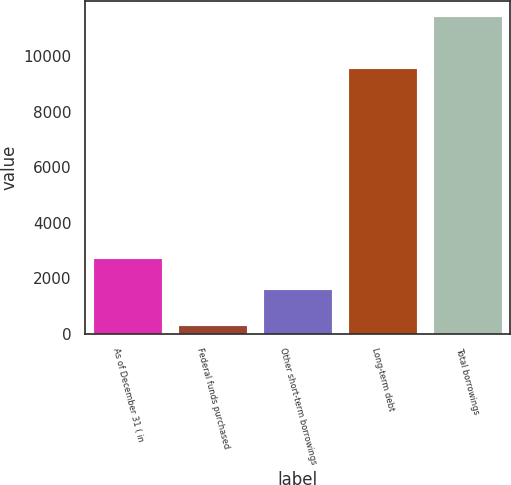Convert chart. <chart><loc_0><loc_0><loc_500><loc_500><bar_chart><fcel>As of December 31 ( in<fcel>Federal funds purchased<fcel>Other short-term borrowings<fcel>Long-term debt<fcel>Total borrowings<nl><fcel>2687.2<fcel>279<fcel>1574<fcel>9558<fcel>11411<nl></chart> 